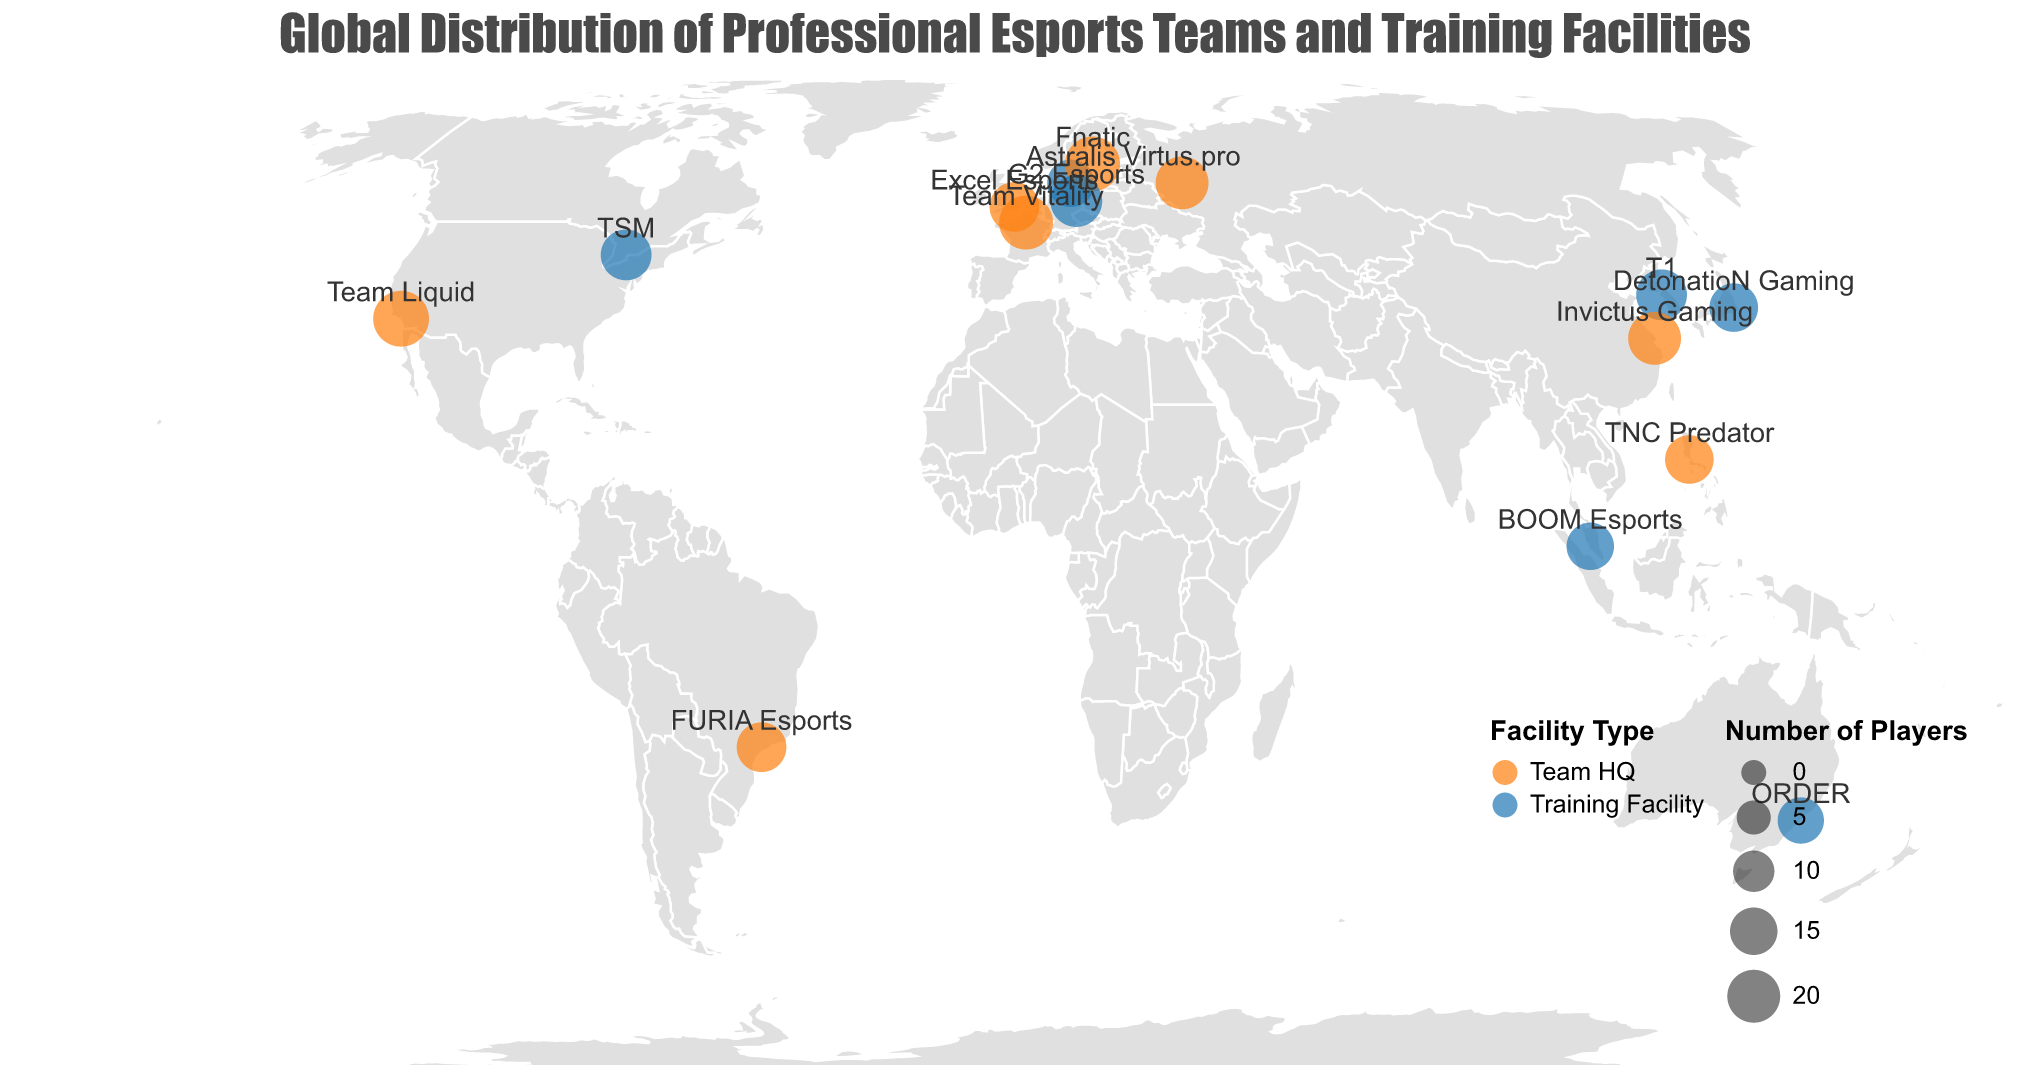How many professional esports teams and training facilities are shown on the map? Count the circles representing the teams and training facilities on the map.
Answer: 15 Which city has the highest number of players in its team or training facility? Identify the largest circle on the map and check the corresponding city in the tooltip.
Answer: Los Angeles What is the total number of players in all the professional esports teams and training facilities? Add up the number of players from all team HQs and training facilities: 23 + 18 + 20 + 15 + 22 + 19 + 17 + 16 + 21 + 18 + 20 + 14 + 16 + 15 + 17 = 271
Answer: 271 Which country has both a team HQ and a training facility represented on the map? Look for countries that have two circles with different colors (one for Team HQ and one for Training Facility) in the map or legend description.
Answer: None Compare the number of players between Fnatic and G2 Esports, which team has more players? Locate the circles for Fnatic (Stockholm) and G2 Esports (Berlin) and compare the number of players in the tooltip.
Answer: Fnatic What is the difference in the number of players between T1 and ORDER? Find the T1 (Seoul) and ORDER (Sydney) circles and calculate the difference: 18 - 14 = 4
Answer: 4 Are there any professional esports teams or training facilities in Africa? Observe the map to check if any circles are present in the African continent.
Answer: No Which is the only city in the United States represented on the map? Look for the circle located in the United States on the map and check its corresponding city in the tooltip.
Answer: Los Angeles How many teams have 20 or more players? Identify the circles with a size indicating 20 or more players and count them. Teams with 20 or more players: Team Liquid (23), Invictus Gaming (20), Fnatic (22), Team Vitality (21), Virtus.pro (20).
Answer: 5 